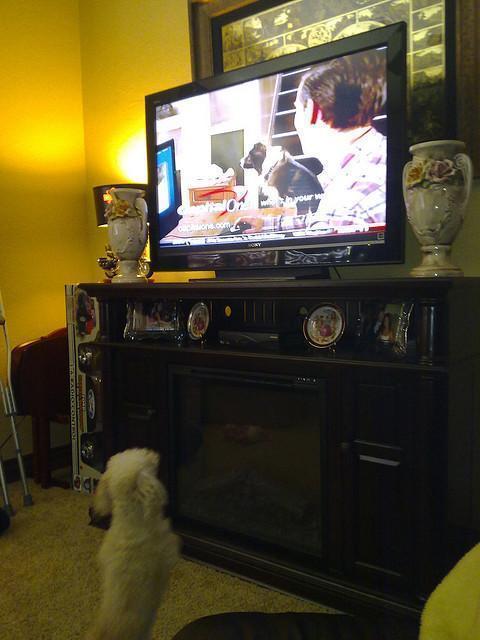What does this dog like on the TV?
Select the accurate answer and provide justification: `Answer: choice
Rationale: srationale.`
Options: Another dog, toys, cats, food. Answer: another dog.
Rationale: Dogs are interested in other dogs, and the dog is looking at the television while there is another dog on the screen. 